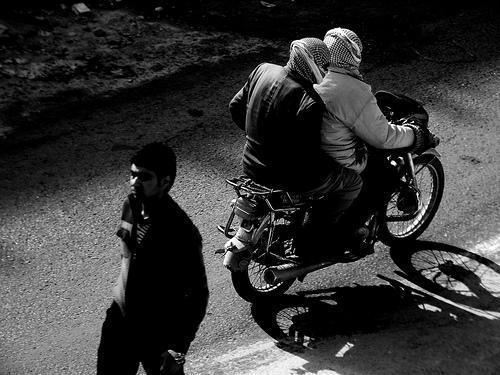How many people are on the bike?
Give a very brief answer. 2. How many wheels are there?
Give a very brief answer. 2. How many people are pictured?
Give a very brief answer. 3. How many people are on the motorcycle?
Give a very brief answer. 2. How many tires are there?
Give a very brief answer. 2. How many bikes are there?
Give a very brief answer. 1. 